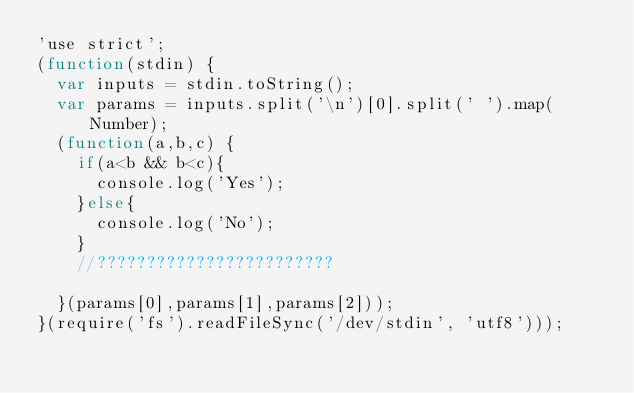Convert code to text. <code><loc_0><loc_0><loc_500><loc_500><_JavaScript_>'use strict';
(function(stdin) { 
  var inputs = stdin.toString();
  var params = inputs.split('\n')[0].split(' ').map(Number);
  (function(a,b,c) {
    if(a<b && b<c){
      console.log('Yes');
    }else{
      console.log('No');
    }
    //????????????????????????
 
  }(params[0],params[1],params[2])); 
}(require('fs').readFileSync('/dev/stdin', 'utf8')));</code> 